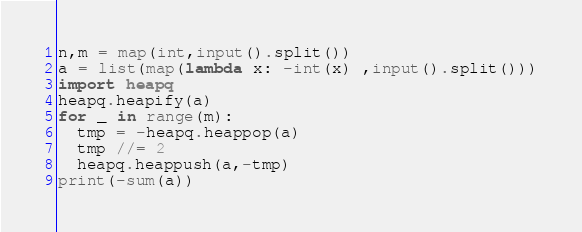<code> <loc_0><loc_0><loc_500><loc_500><_Python_>n,m = map(int,input().split())
a = list(map(lambda x: -int(x) ,input().split()))
import heapq
heapq.heapify(a)
for _ in range(m):
  tmp = -heapq.heappop(a)
  tmp //= 2
  heapq.heappush(a,-tmp)
print(-sum(a))</code> 